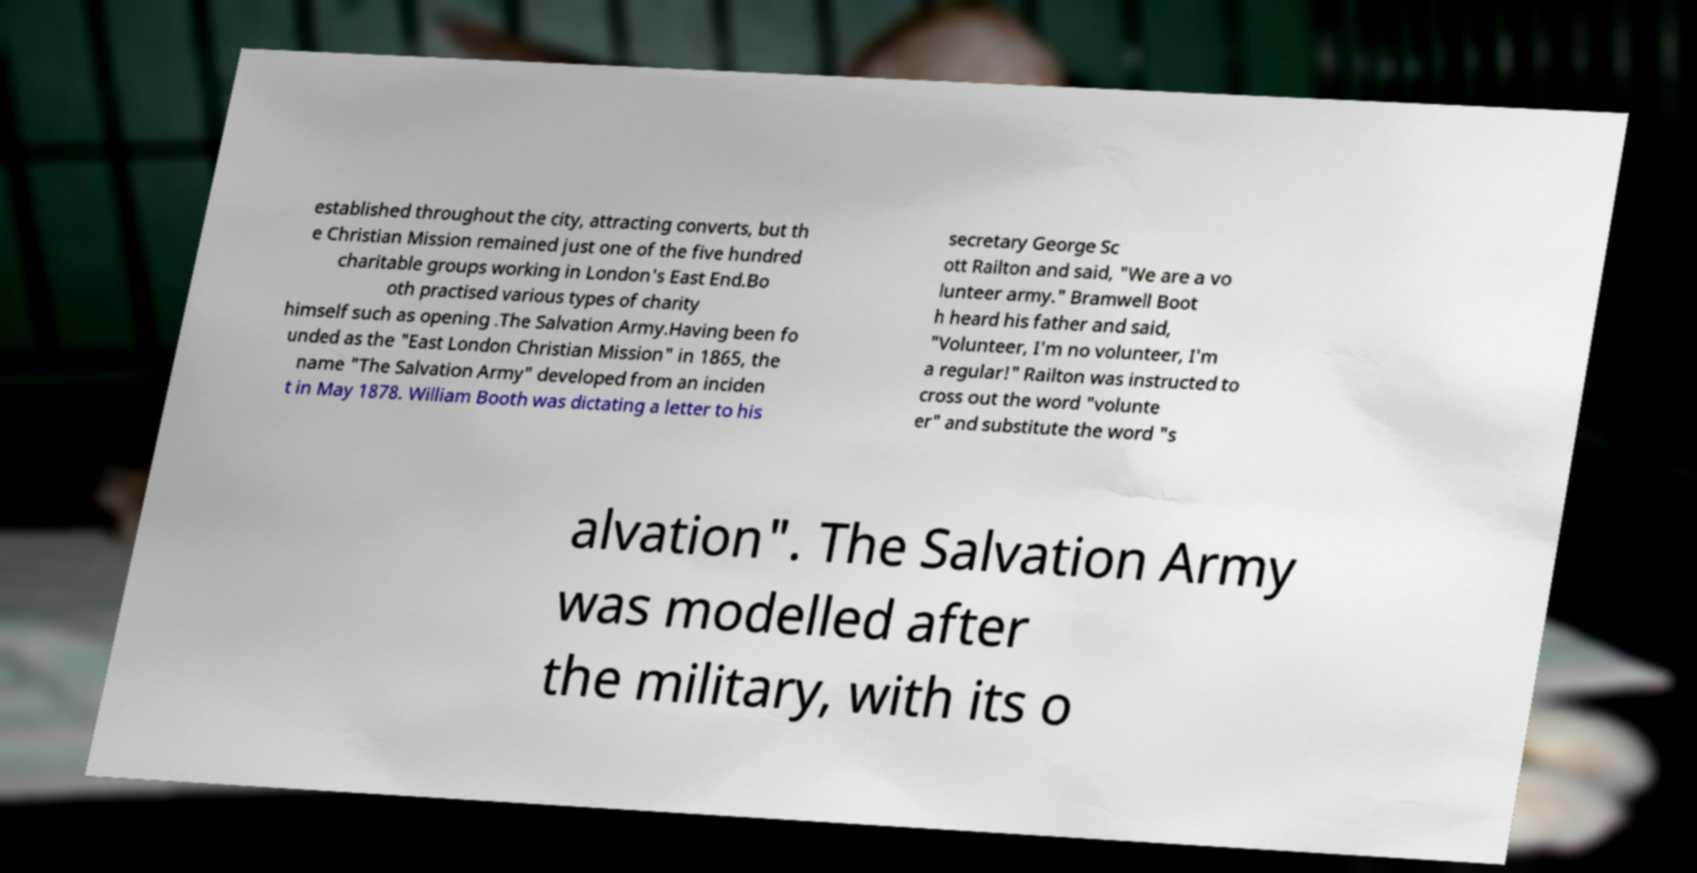For documentation purposes, I need the text within this image transcribed. Could you provide that? established throughout the city, attracting converts, but th e Christian Mission remained just one of the five hundred charitable groups working in London's East End.Bo oth practised various types of charity himself such as opening .The Salvation Army.Having been fo unded as the "East London Christian Mission" in 1865, the name "The Salvation Army" developed from an inciden t in May 1878. William Booth was dictating a letter to his secretary George Sc ott Railton and said, "We are a vo lunteer army." Bramwell Boot h heard his father and said, "Volunteer, I'm no volunteer, I'm a regular!" Railton was instructed to cross out the word "volunte er" and substitute the word "s alvation". The Salvation Army was modelled after the military, with its o 